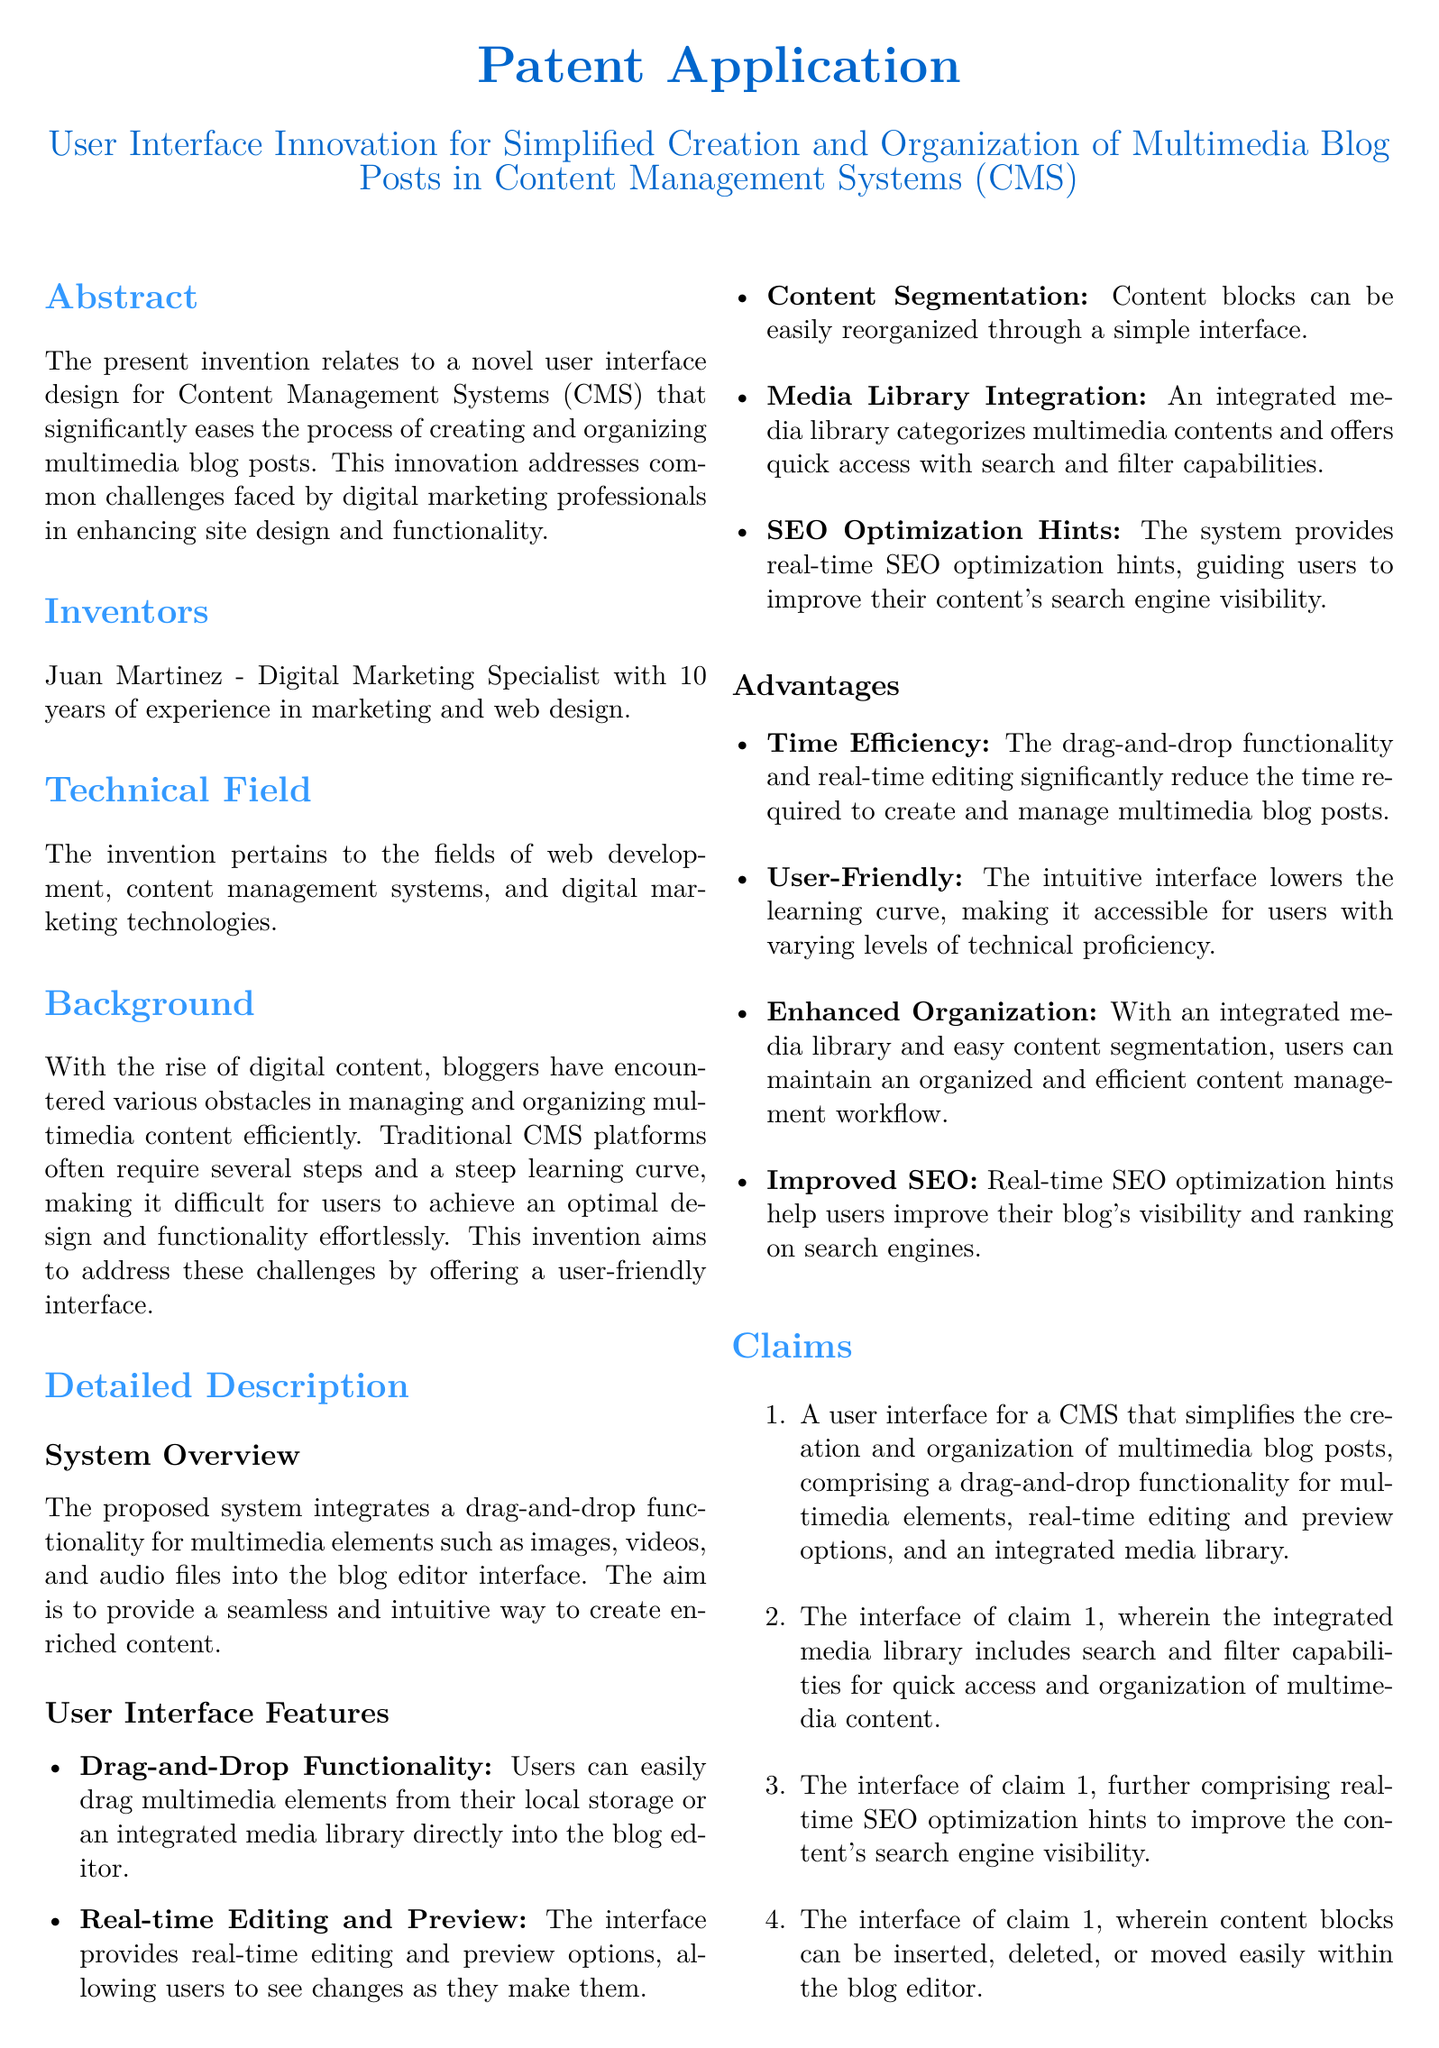What is the title of the patent application? The title of the patent application is located at the top of the document and summarizes the innovation being presented.
Answer: User Interface Innovation for Simplified Creation and Organization of Multimedia Blog Posts in Content Management Systems (CMS) Who is the inventor of the innovation? The inventor's name is provided in the section dedicated to the inventors, detailing their background in marketing and web design.
Answer: Juan Martinez What is one key feature of the proposed user interface? The document lists features under user interface features, highlighting a significant functionality of the innovation.
Answer: Drag-and-Drop Functionality How does the system enhance SEO? The document mentions a feature that provides specific guidance to help improve search engine visibility as part of the system's advantages.
Answer: Real-time SEO optimization hints What is the main purpose of this invention? The background section explains the common challenges faced by users which the invention aims to alleviate.
Answer: To simplify the creation and organization of multimedia blog posts How many claims are made in the patent application? The claims section lists the number of specific features that are being claimed in this patent application.
Answer: Four What notable advantage is mentioned related to learning curves? The advantages section outlines how the proposed system affects the user's learning experience, making it easier for users.
Answer: Lowering the learning curve What type of content management system does this innovation relate to? The technical field section specifies the context in which the invention is relevant.
Answer: Content Management Systems What functionality allows users to preview changes? The document describes a feature that allows users to see alterations in real time while editing, highlighting its utility.
Answer: Real-time editing and preview 